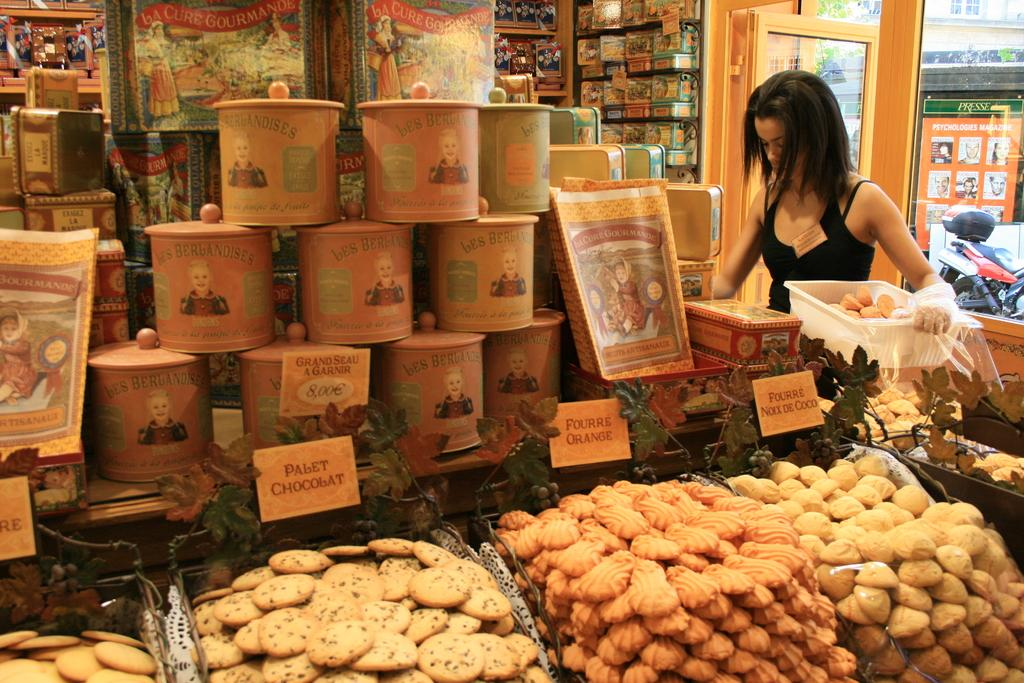<image>
Provide a brief description of the given image. Pabet chocolat, fourre orange, and fourre Noxx de coco laid out in store. 